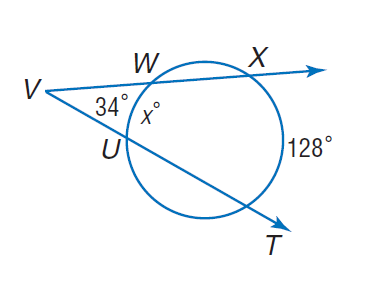Question: Find x.
Choices:
A. 34
B. 49
C. 60
D. 128
Answer with the letter. Answer: C 